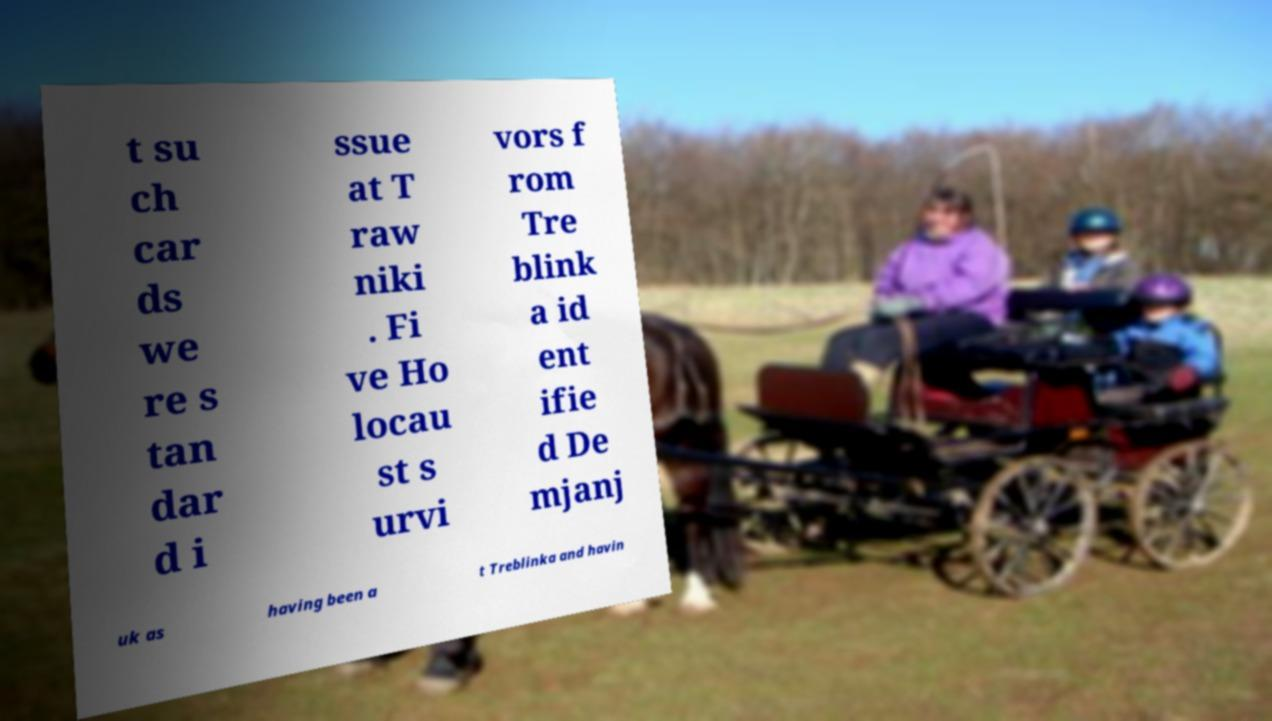Could you assist in decoding the text presented in this image and type it out clearly? t su ch car ds we re s tan dar d i ssue at T raw niki . Fi ve Ho locau st s urvi vors f rom Tre blink a id ent ifie d De mjanj uk as having been a t Treblinka and havin 